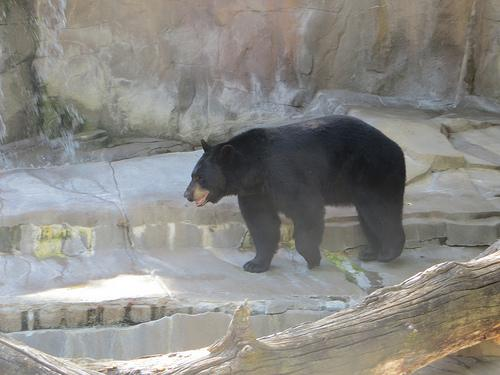Question: how many legs does this animal have?
Choices:
A. 3.
B. 2.
C. 4.
D. 1.
Answer with the letter. Answer: C Question: what type of animal is this?
Choices:
A. Donkey.
B. Cat.
C. Bear.
D. Dog.
Answer with the letter. Answer: C Question: where could this photo have been taken?
Choices:
A. In bedroom.
B. A police station.
C. A forest.
D. Zoo.
Answer with the letter. Answer: D Question: why might the area bear is in be designed as it is?
Choices:
A. So that it will be happy.
B. To be cool.
C. To look natural.
D. To make sense.
Answer with the letter. Answer: C 